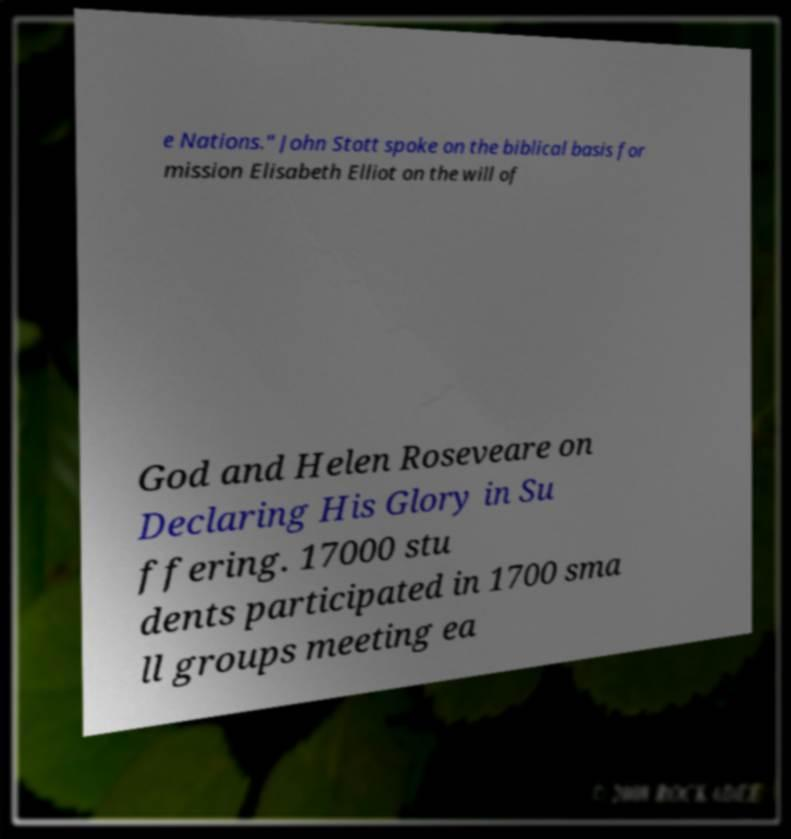There's text embedded in this image that I need extracted. Can you transcribe it verbatim? e Nations." John Stott spoke on the biblical basis for mission Elisabeth Elliot on the will of God and Helen Roseveare on Declaring His Glory in Su ffering. 17000 stu dents participated in 1700 sma ll groups meeting ea 